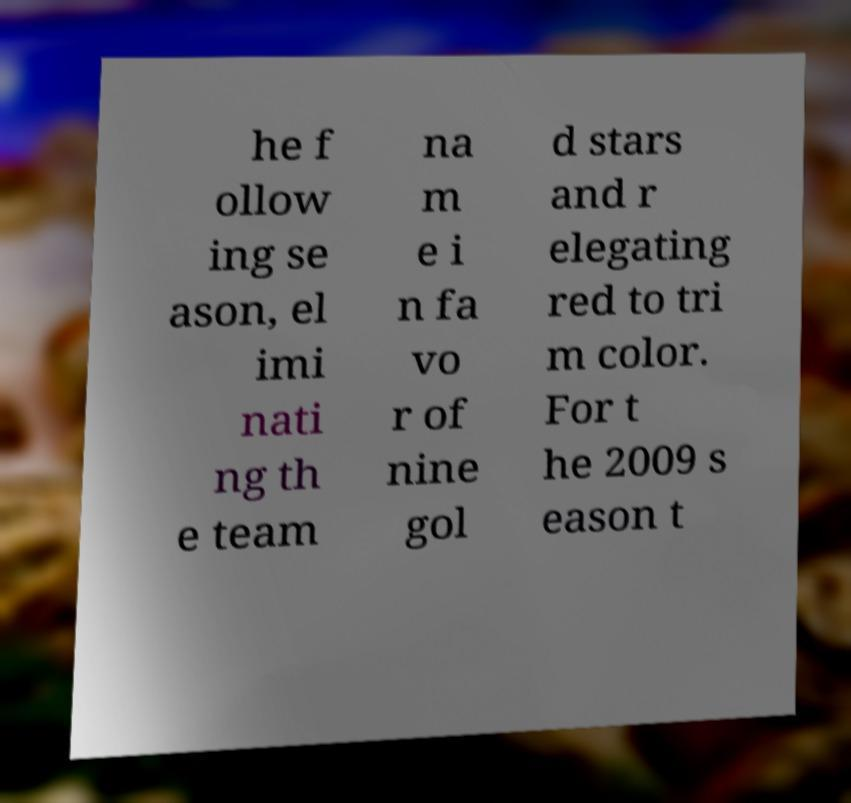Could you assist in decoding the text presented in this image and type it out clearly? he f ollow ing se ason, el imi nati ng th e team na m e i n fa vo r of nine gol d stars and r elegating red to tri m color. For t he 2009 s eason t 